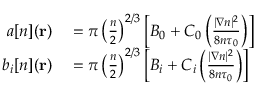<formula> <loc_0><loc_0><loc_500><loc_500>\begin{array} { r l } { a [ n ] ( r ) } & = \pi \left ( \frac { n } { 2 } \right ) ^ { 2 / 3 } \left [ B _ { 0 } + C _ { 0 } \left ( \frac { | \nabla n | ^ { 2 } } { 8 n \tau _ { 0 } } \right ) \right ] } \\ { b _ { i } [ n ] ( r ) } & = \pi \left ( \frac { n } { 2 } \right ) ^ { 2 / 3 } \left [ B _ { i } + C _ { i } \left ( \frac { | \nabla n | ^ { 2 } } { 8 n \tau _ { 0 } } \right ) \right ] } \end{array}</formula> 